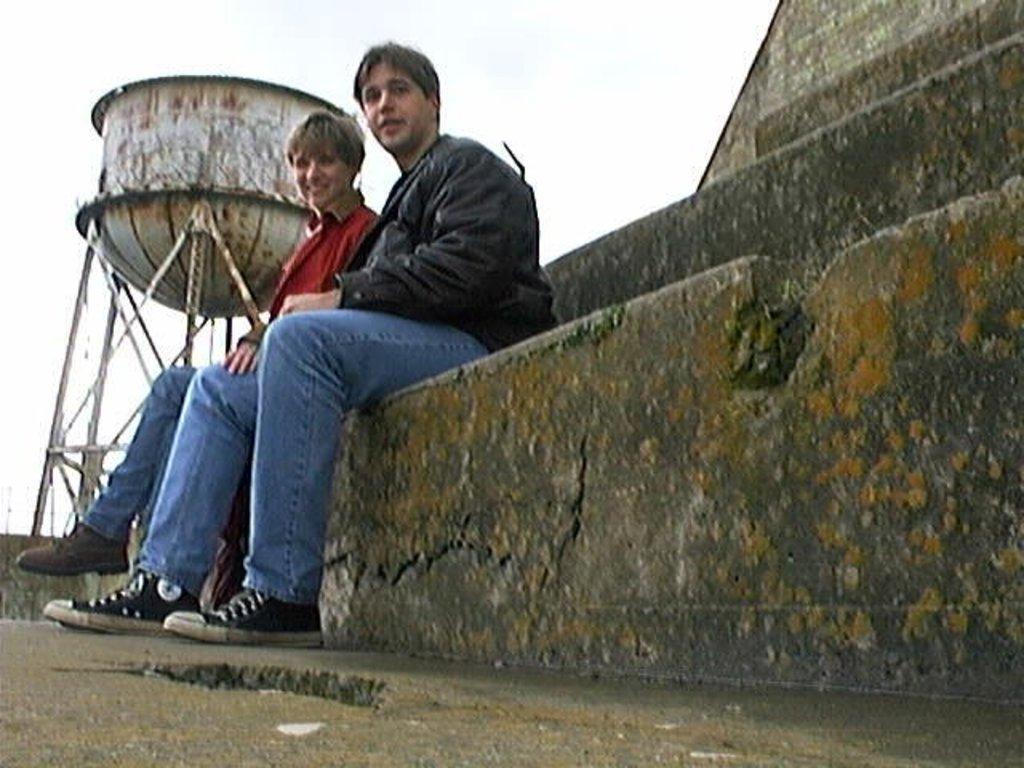Please provide a concise description of this image. In this image I can see there are two persons sitting on the rock and I can see a water tank visible on the left side and I can see the sky visible at the top. 